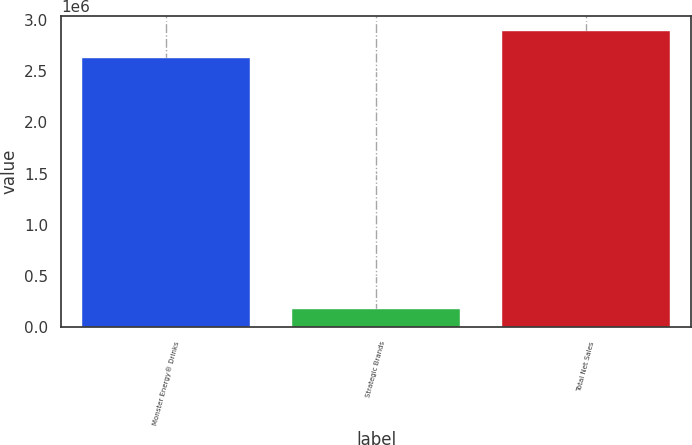<chart> <loc_0><loc_0><loc_500><loc_500><bar_chart><fcel>Monster Energy® Drinks<fcel>Strategic Brands<fcel>Total Net Sales<nl><fcel>2.627e+06<fcel>179677<fcel>2.89199e+06<nl></chart> 